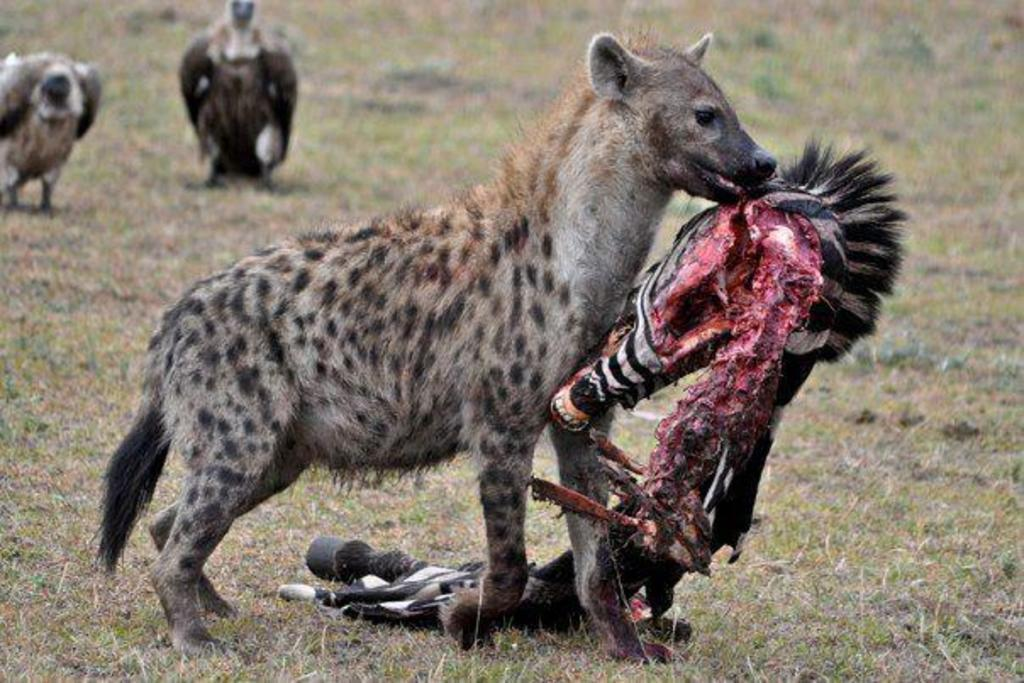What is the main action taking place in the image? There is an animal holding the flesh of another animal in the image. What type of environment is depicted in the background? There is grass visible in the background of the image. Are there any other animals present in the image? Yes, there are other animals present in the background of the image. What type of unit is being used to measure the peace in the image? There is no mention of any unit or measurement of peace in the image. 